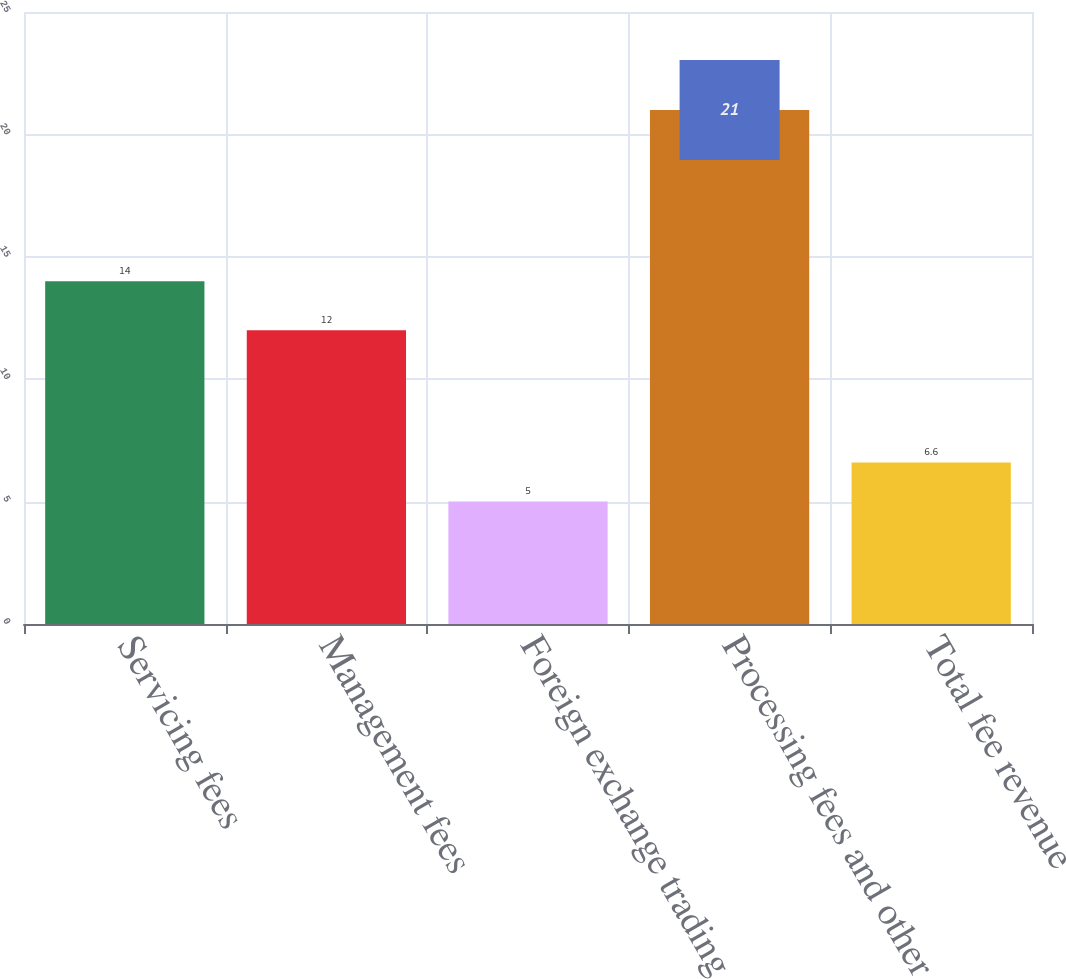Convert chart. <chart><loc_0><loc_0><loc_500><loc_500><bar_chart><fcel>Servicing fees<fcel>Management fees<fcel>Foreign exchange trading<fcel>Processing fees and other<fcel>Total fee revenue<nl><fcel>14<fcel>12<fcel>5<fcel>21<fcel>6.6<nl></chart> 